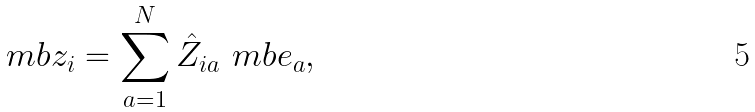Convert formula to latex. <formula><loc_0><loc_0><loc_500><loc_500>\ m b { z } _ { i } = \sum _ { a = 1 } ^ { N } \hat { Z } _ { i a } \ m b { e } _ { a } ,</formula> 